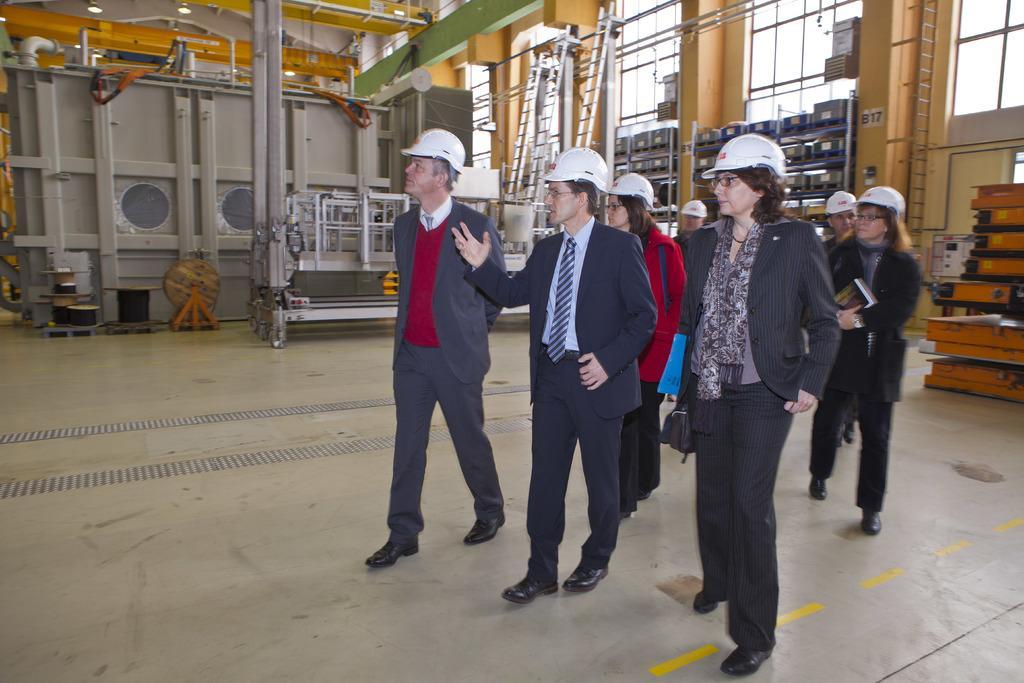How would you summarize this image in a sentence or two? In this image I can see a group of people are standing and wearing white color helmets. Some of them are wearing coats. In the background I can see metal objects, ladders and some other objects. I can also see windows over here. 